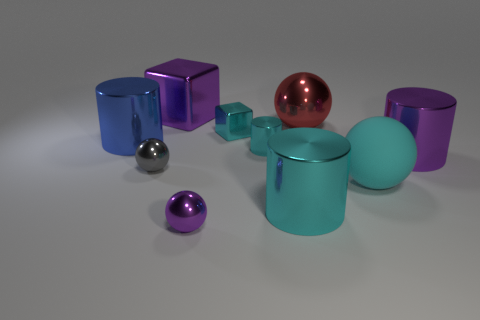There is a purple block that is the same size as the blue cylinder; what is its material?
Keep it short and to the point. Metal. Do the cyan cylinder that is in front of the tiny gray metal ball and the metallic object that is to the right of the big red shiny ball have the same size?
Offer a terse response. Yes. There is a tiny metallic block; are there any small cyan objects left of it?
Offer a very short reply. No. What color is the metallic cylinder that is in front of the large purple object that is in front of the red metal sphere?
Your answer should be very brief. Cyan. Are there fewer large cyan shiny cylinders than tiny green shiny cylinders?
Make the answer very short. No. What number of other small metallic things are the same shape as the tiny gray thing?
Offer a very short reply. 1. The sphere that is the same size as the red metal object is what color?
Provide a short and direct response. Cyan. Are there an equal number of small purple metallic objects in front of the purple sphere and tiny gray objects that are to the right of the large blue thing?
Your answer should be compact. No. Is there a cyan shiny block of the same size as the blue cylinder?
Make the answer very short. No. The gray thing has what size?
Your answer should be very brief. Small. 